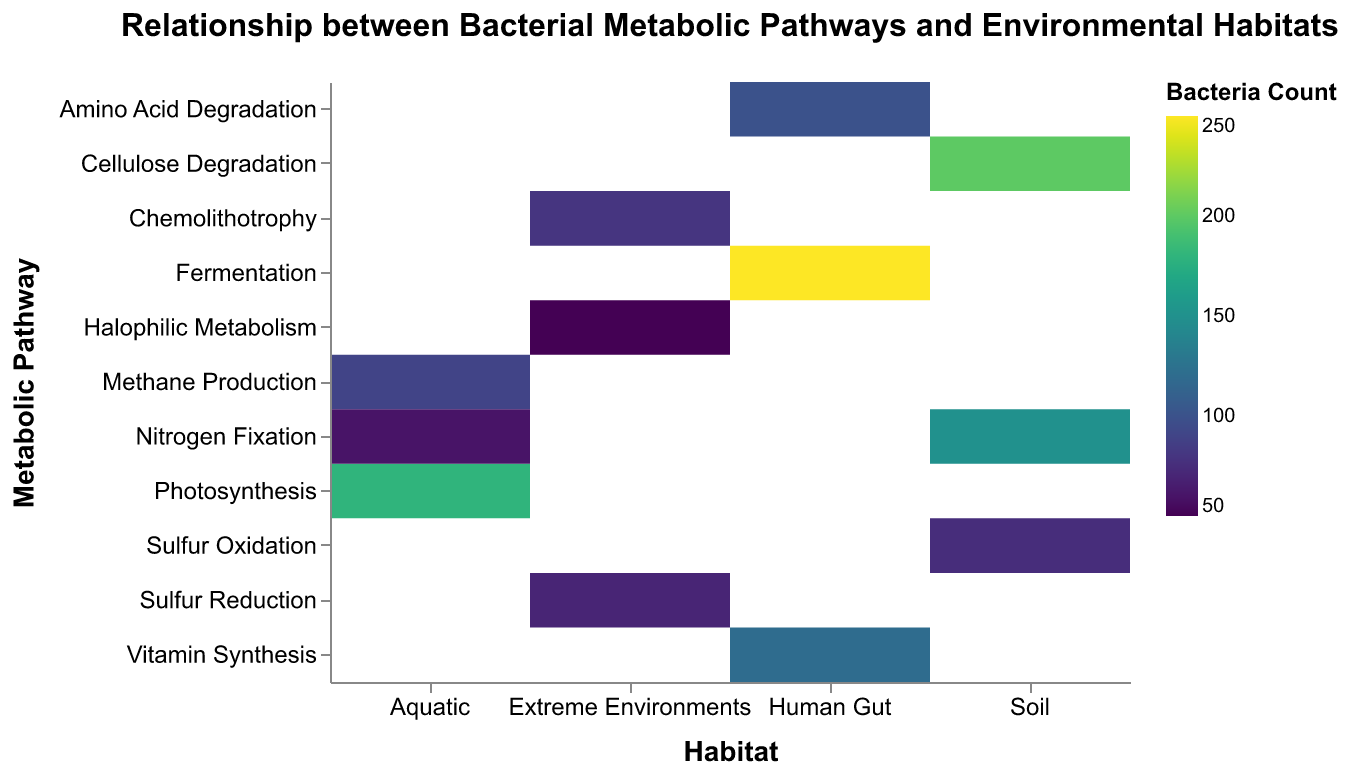What is the title of the figure? The title of the figure is generally located at the top center of the chart. It summarizes the main topic of the figure. In this case, the title provided clearly states what the chart represents.
Answer: Relationship between Bacterial Metabolic Pathways and Environmental Habitats Which habitat has the highest total bacteria count? To determine which habitat has the highest total bacteria count, sum up the bacteria counts for each metabolic pathway within each habitat. Compare the totals among the habitats.
Answer: Human Gut Which metabolic pathway in the Soil habitat has the largest bacteria count? Look at the bacterial counts for each metabolic pathway within the Soil habitat. Identify the highest count.
Answer: Cellulose Degradation Compare the bacteria count for Methane Production in the Aquatic habitat to Vitamin Synthesis in the Human Gut habitat. Which one is higher? Find the bacterial counts for Methane Production in the Aquatic habitat and Vitamin Synthesis in the Human Gut habitat. Compare these two values.
Answer: Vitamin Synthesis What is the bacteria count for Nitrogen Fixation in the Aquatic habitat? Locate the bacterial count for Nitrogen Fixation within the Aquatic habitat in the chart.
Answer: 60 How many metabolic pathways are represented in the Extreme Environments habitat? Count the number of different metabolic pathways listed for the Extreme Environments habitat.
Answer: 3 Calculate the total bacteria count for the Soil habitat. Sum the bacteria counts for all the metabolic pathways listed under the Soil habitat (150 + 200 + 75).
Answer: 425 Which metabolic pathway exhibits the most diverse representation across different habitats? Identify which metabolic pathway appears in the highest number of different habitats. This can be found by checking each pathway and counting the unique habitats it appears in.
Answer: Nitrogen Fixation Between Fermentation and Amino Acid Degradation in the Human Gut habitat, which has more bacterial counts? Compare the bacterial counts for Fermentation and Amino Acid Degradation within the Human Gut habitat.
Answer: Fermentation What is the color scale used to represent the bacteria count? The color scale can be deduced from the legend, which describes the mapping of bacterial counts to specific colors.
Answer: viridis 